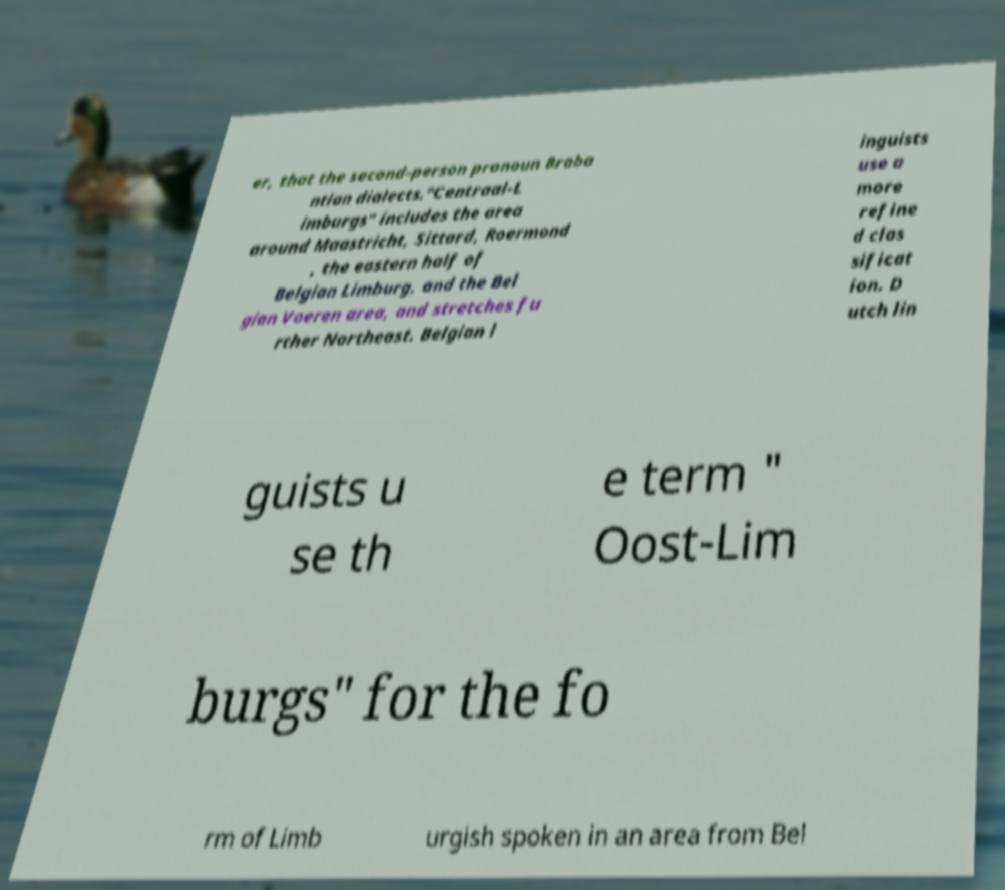Please identify and transcribe the text found in this image. er, that the second-person pronoun Braba ntian dialects."Centraal-L imburgs" includes the area around Maastricht, Sittard, Roermond , the eastern half of Belgian Limburg, and the Bel gian Voeren area, and stretches fu rther Northeast. Belgian l inguists use a more refine d clas sificat ion. D utch lin guists u se th e term " Oost-Lim burgs" for the fo rm of Limb urgish spoken in an area from Bel 